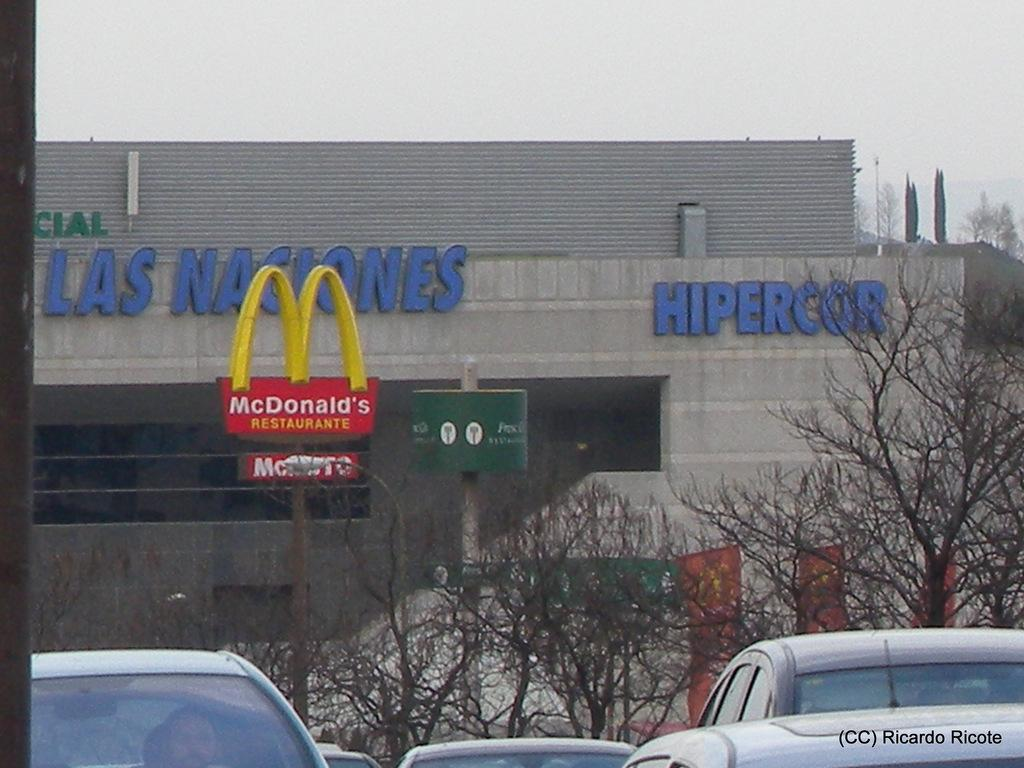What types of objects are present in the image? There are vehicles in the image. How are the vehicles arranged? The vehicles are arranged from left to right. What other elements can be seen in the image besides the vehicles? There are trees, boards on a pole, and a building in the background. Where is the throne located in the image? There is no throne present in the image. What territory does the image represent? The image does not represent any specific territory. 